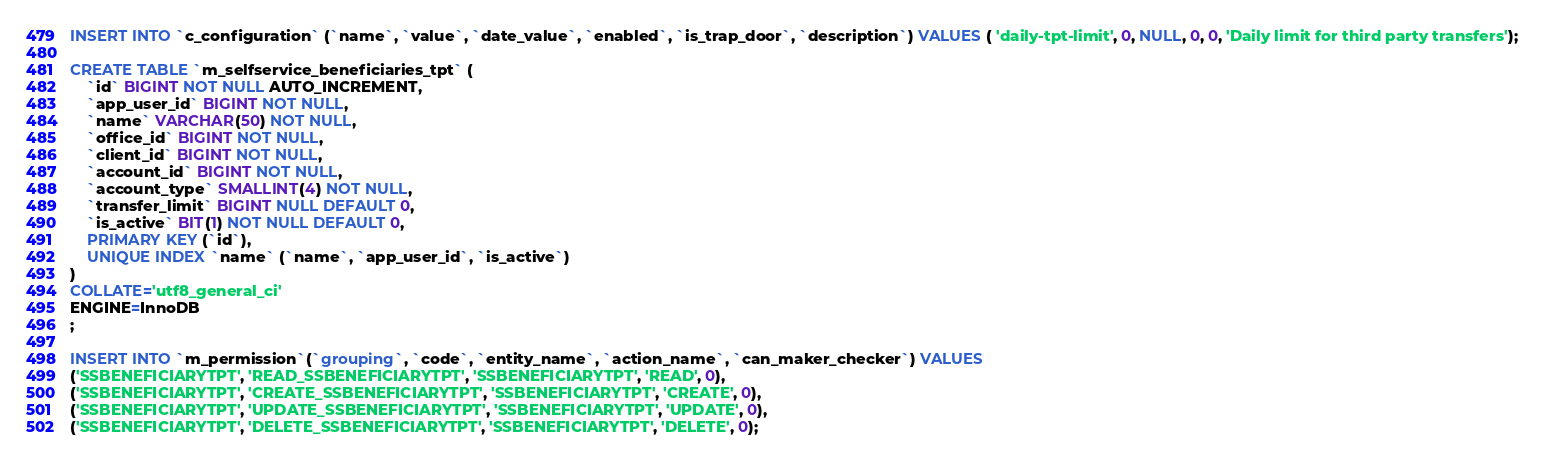Convert code to text. <code><loc_0><loc_0><loc_500><loc_500><_SQL_>INSERT INTO `c_configuration` (`name`, `value`, `date_value`, `enabled`, `is_trap_door`, `description`) VALUES ( 'daily-tpt-limit', 0, NULL, 0, 0, 'Daily limit for third party transfers');

CREATE TABLE `m_selfservice_beneficiaries_tpt` (
	`id` BIGINT NOT NULL AUTO_INCREMENT,
	`app_user_id` BIGINT NOT NULL,
	`name` VARCHAR(50) NOT NULL,
	`office_id` BIGINT NOT NULL,
	`client_id` BIGINT NOT NULL,
	`account_id` BIGINT NOT NULL,
	`account_type` SMALLINT(4) NOT NULL,
	`transfer_limit` BIGINT NULL DEFAULT 0,
	`is_active` BIT(1) NOT NULL DEFAULT 0,
	PRIMARY KEY (`id`),
	UNIQUE INDEX `name` (`name`, `app_user_id`, `is_active`)
)
COLLATE='utf8_general_ci'
ENGINE=InnoDB
;

INSERT INTO `m_permission`(`grouping`, `code`, `entity_name`, `action_name`, `can_maker_checker`) VALUES
('SSBENEFICIARYTPT', 'READ_SSBENEFICIARYTPT', 'SSBENEFICIARYTPT', 'READ', 0),
('SSBENEFICIARYTPT', 'CREATE_SSBENEFICIARYTPT', 'SSBENEFICIARYTPT', 'CREATE', 0),
('SSBENEFICIARYTPT', 'UPDATE_SSBENEFICIARYTPT', 'SSBENEFICIARYTPT', 'UPDATE', 0),
('SSBENEFICIARYTPT', 'DELETE_SSBENEFICIARYTPT', 'SSBENEFICIARYTPT', 'DELETE', 0);
</code> 